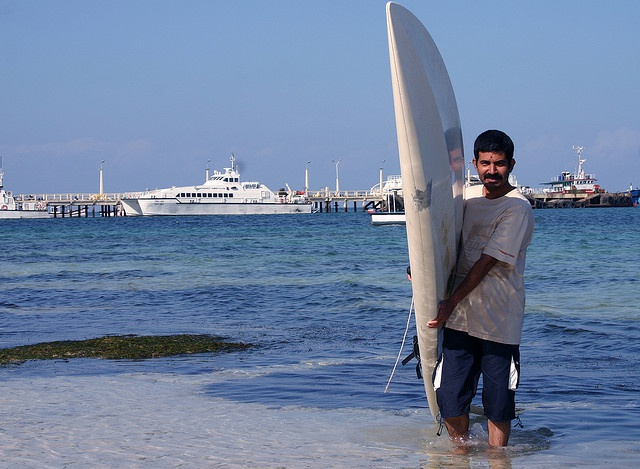Describe the objects in this image and their specific colors. I can see people in gray, black, and brown tones, surfboard in gray, darkgray, and tan tones, boat in gray, lightgray, and darkgray tones, boat in gray, darkgray, lightgray, and black tones, and boat in gray, lightgray, and darkgray tones in this image. 